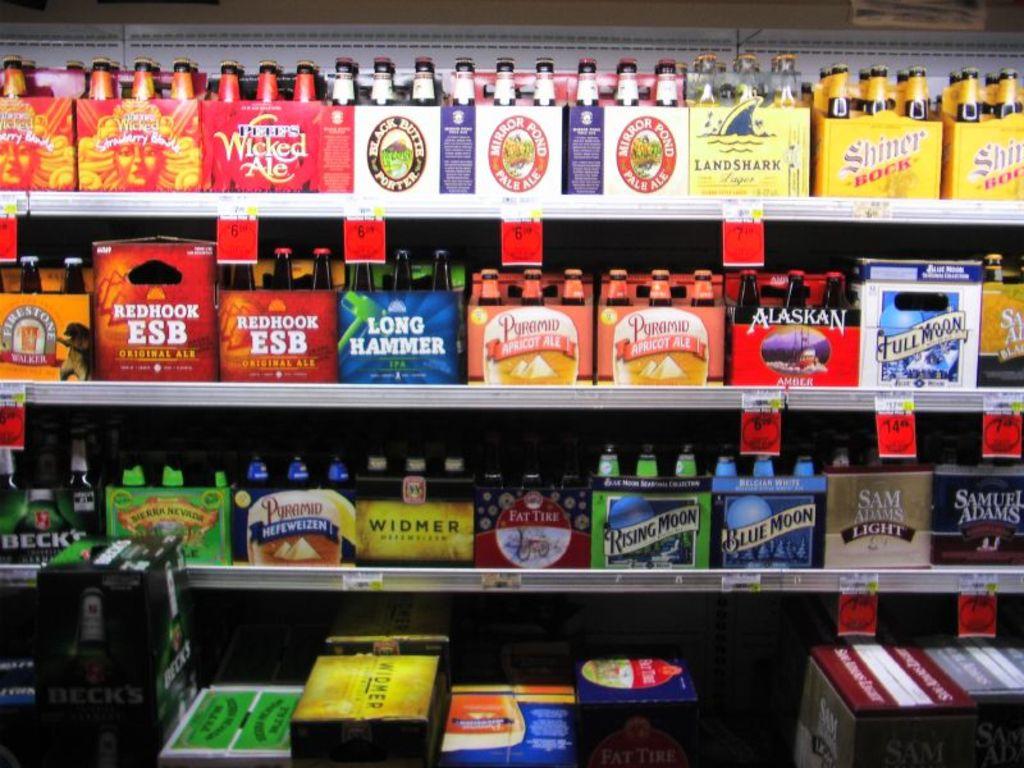What brand of drinks are on the top shelf in the right?
Give a very brief answer. Shiner. Is sam adams a brand featured?
Your answer should be compact. Yes. 